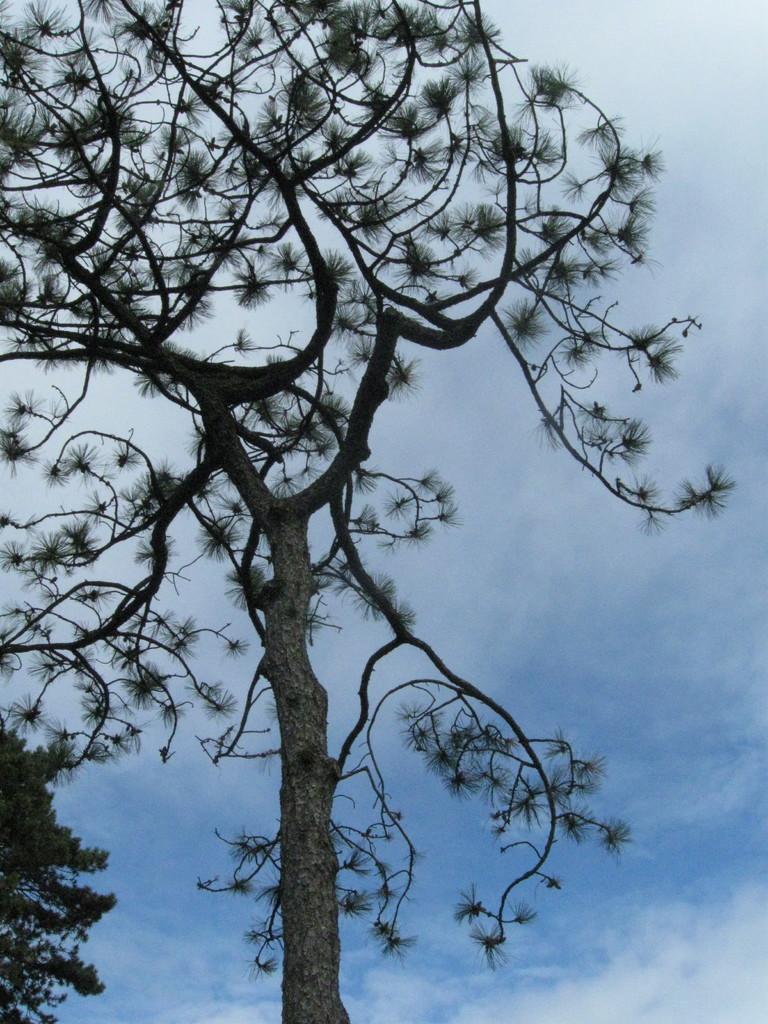Please provide a concise description of this image. In this image we can see a tree. In the background there is a sky. 